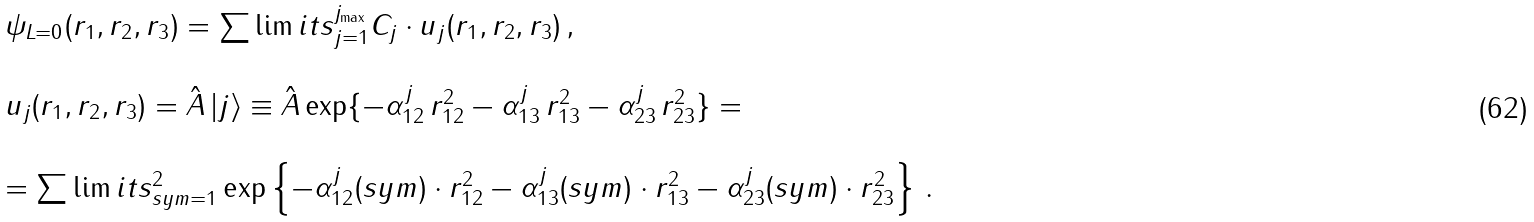Convert formula to latex. <formula><loc_0><loc_0><loc_500><loc_500>\begin{array} { l c r } \psi _ { L = 0 } ( r _ { 1 } , r _ { 2 } , r _ { 3 } ) = \sum \lim i t s _ { j = 1 } ^ { j _ { \max } } C _ { j } \cdot u _ { j } ( r _ { 1 } , r _ { 2 } , r _ { 3 } ) \, , \\ \\ u _ { j } ( r _ { 1 } , r _ { 2 } , r _ { 3 } ) = \hat { A } \, | j \rangle \equiv \hat { A } \exp \{ - \alpha _ { 1 2 } ^ { j } \, r _ { 1 2 } ^ { 2 } - \alpha _ { 1 3 } ^ { j } \, r _ { 1 3 } ^ { 2 } - \alpha _ { 2 3 } ^ { j } \, r _ { 2 3 } ^ { 2 } \} = \\ \\ = \sum \lim i t s _ { s y m = 1 } ^ { 2 } \exp \left \{ - \alpha _ { 1 2 } ^ { j } ( s y m ) \cdot r _ { 1 2 } ^ { 2 } - \alpha _ { 1 3 } ^ { j } ( s y m ) \cdot r _ { 1 3 } ^ { 2 } - \alpha _ { 2 3 } ^ { j } ( s y m ) \cdot r _ { 2 3 } ^ { 2 } \right \} \, . \end{array}</formula> 